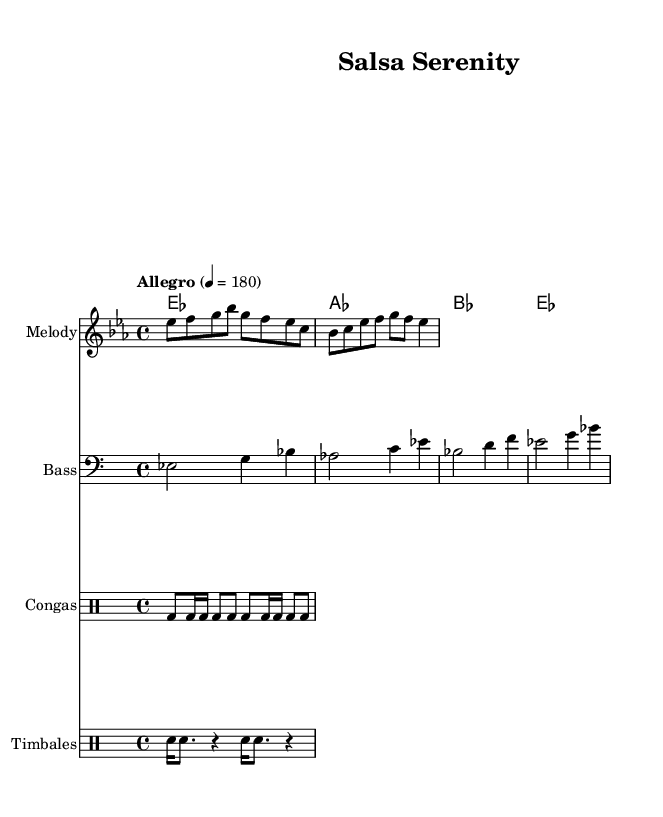What is the key signature of this music? The key signature has three flats indicated on the staff, which corresponds to E flat major.
Answer: E flat major What is the time signature? The time signature is found at the beginning of the staff, indicated as 4 over 4, meaning there are four beats in each measure and a quarter note receives one beat.
Answer: 4/4 What is the tempo marking provided? The tempo marking appears as "Allegro" with a metronome marking of quarter note = 180, indicating a fast pace for the music.
Answer: Allegro 4 = 180 How many measure are in the melody section? The melody section consists of four measures, as can be calculated by counting the groups of notes separated by vertical lines in the music.
Answer: 4 What type of rhythmic instruments are indicated in the score? The score lists Congas and Timbales, which are traditional Latin rhythmic instruments commonly used in salsa music.
Answer: Congas, Timbales Which note has the highest pitch in the melody? By analyzing the notes in the melody, G is the highest pitch since it appears three times, shown in the second measure on the staff.
Answer: G What is the feel of the bass line in relation to the melody? The bass line follows a supportive role, providing harmonic foundation by playing root notes that align with the melody, creating a sense of groove characteristic of salsa music.
Answer: Groove 